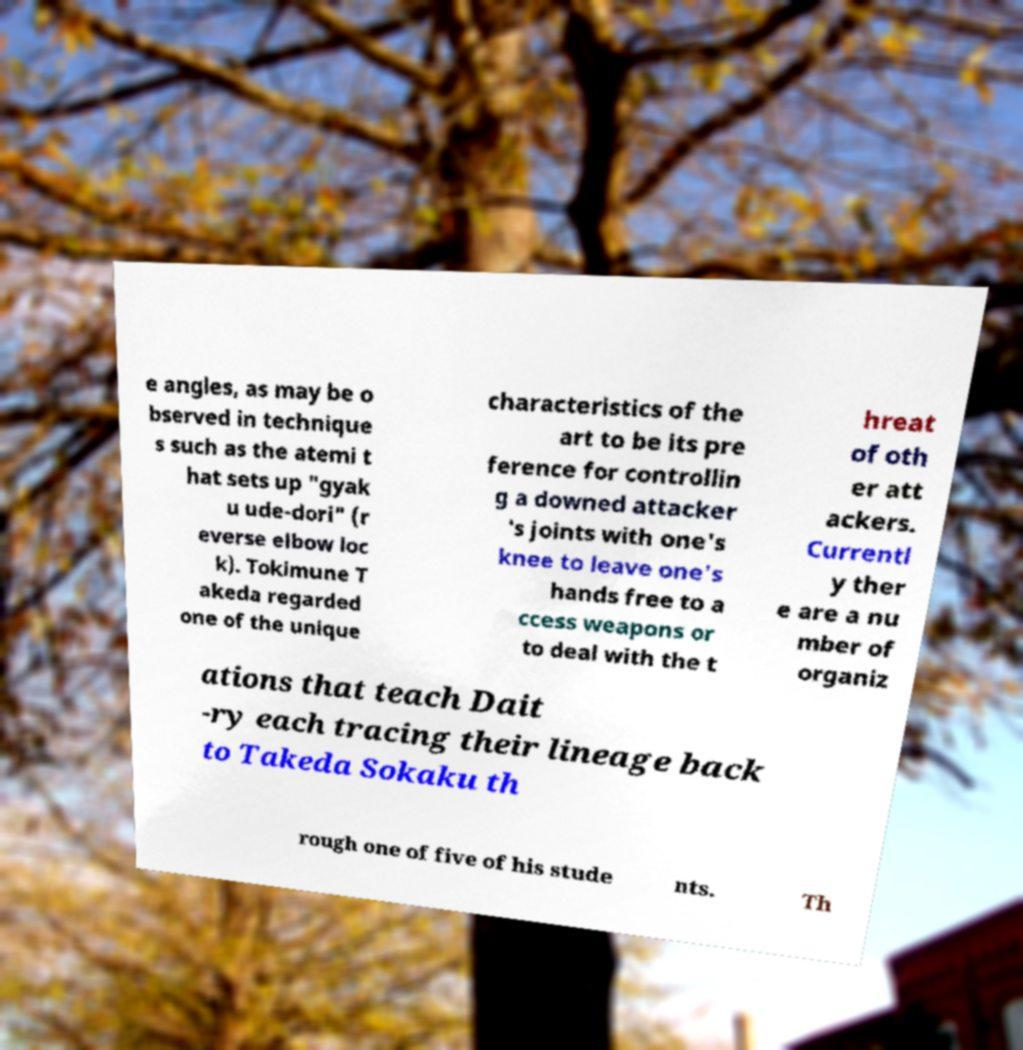Can you read and provide the text displayed in the image?This photo seems to have some interesting text. Can you extract and type it out for me? e angles, as may be o bserved in technique s such as the atemi t hat sets up "gyak u ude-dori" (r everse elbow loc k). Tokimune T akeda regarded one of the unique characteristics of the art to be its pre ference for controllin g a downed attacker 's joints with one's knee to leave one's hands free to a ccess weapons or to deal with the t hreat of oth er att ackers. Currentl y ther e are a nu mber of organiz ations that teach Dait -ry each tracing their lineage back to Takeda Sokaku th rough one of five of his stude nts. Th 